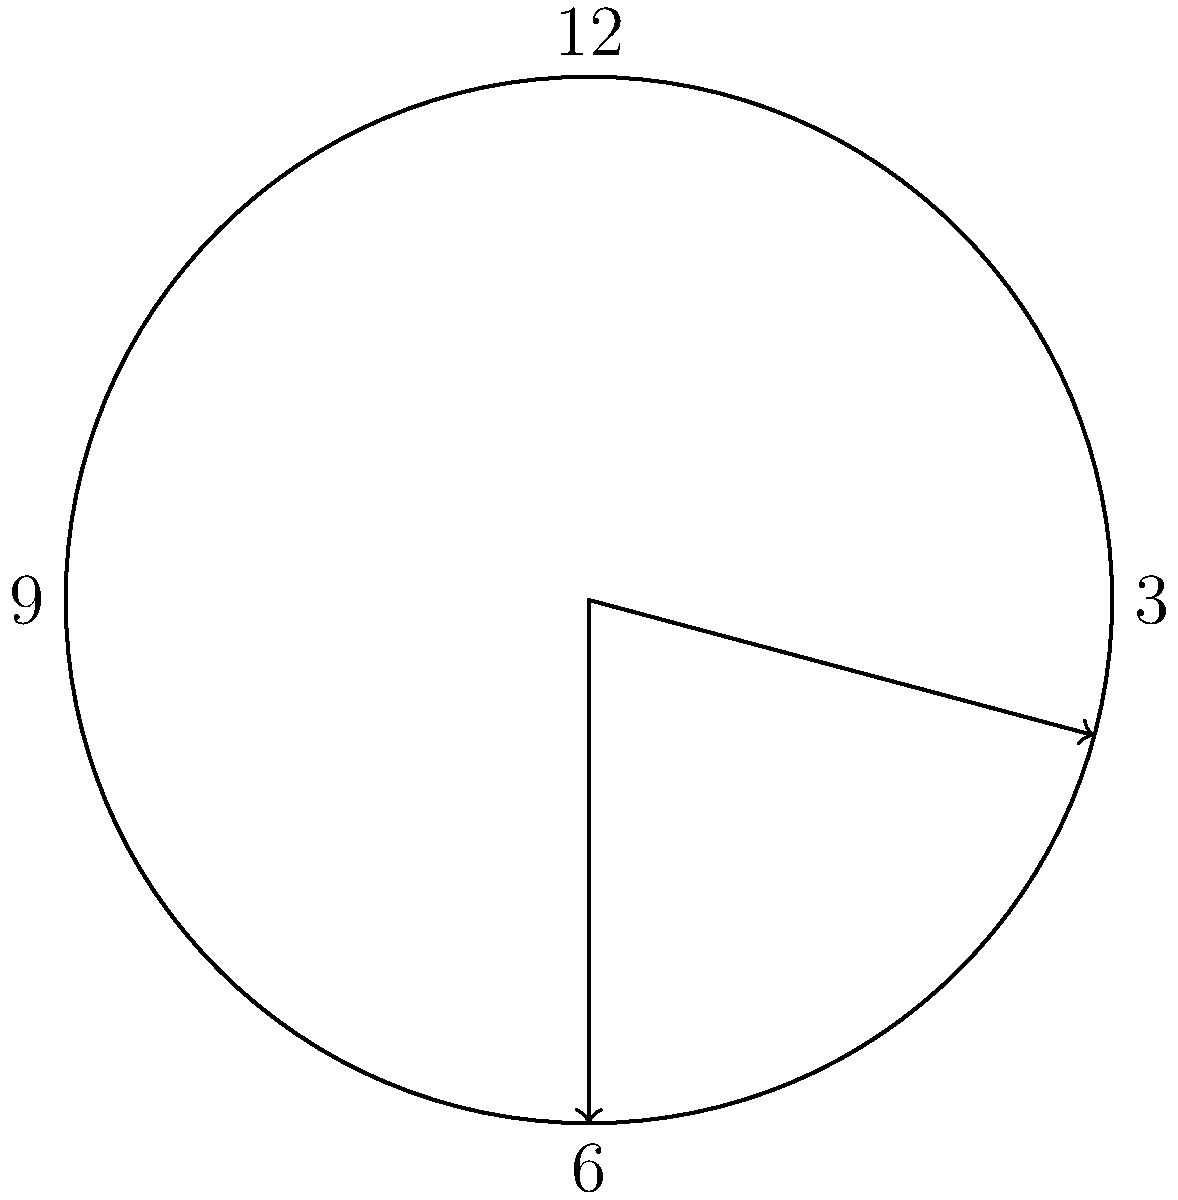At 3:30, what is the angle formed between the hour hand and the minute hand of an analog clock? To find the angle between the hour and minute hands, we need to follow these steps:

1. Calculate the angle of the hour hand from 12 o'clock:
   - Each hour represents 30° (360° ÷ 12 = 30°)
   - At 3:30, the hour hand has moved 3.5 hours
   - Angle of hour hand = $3.5 \times 30° = 105°$

2. Calculate the angle of the minute hand from 12 o'clock:
   - Each minute represents 6° (360° ÷ 60 = 6°)
   - At 30 minutes past, the minute hand has moved 30 minutes
   - Angle of minute hand = $30 \times 6° = 180°$

3. Find the absolute difference between these angles:
   $|180° - 105°| = 75°$

Therefore, the angle between the hour hand and the minute hand at 3:30 is 75°.
Answer: 75° 